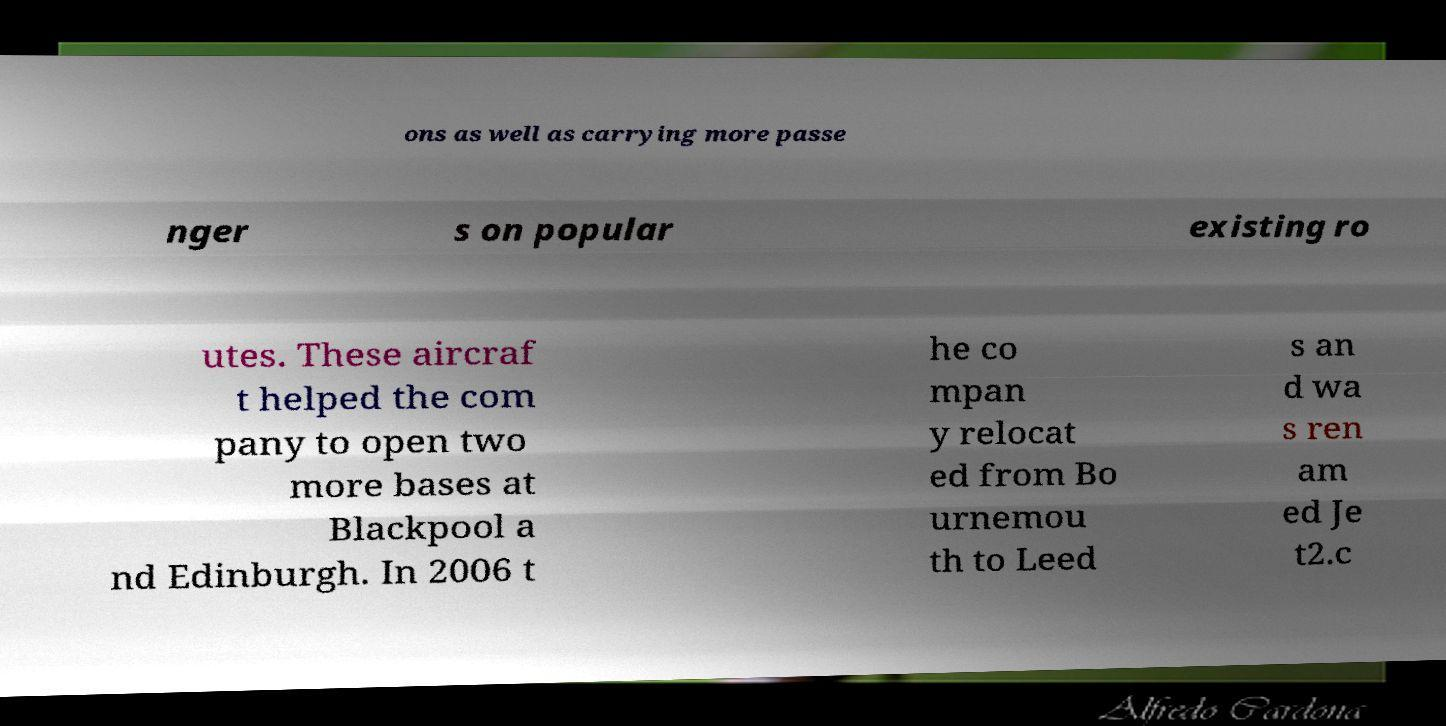There's text embedded in this image that I need extracted. Can you transcribe it verbatim? ons as well as carrying more passe nger s on popular existing ro utes. These aircraf t helped the com pany to open two more bases at Blackpool a nd Edinburgh. In 2006 t he co mpan y relocat ed from Bo urnemou th to Leed s an d wa s ren am ed Je t2.c 